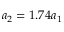Convert formula to latex. <formula><loc_0><loc_0><loc_500><loc_500>a _ { 2 } = 1 . 7 4 a _ { 1 }</formula> 